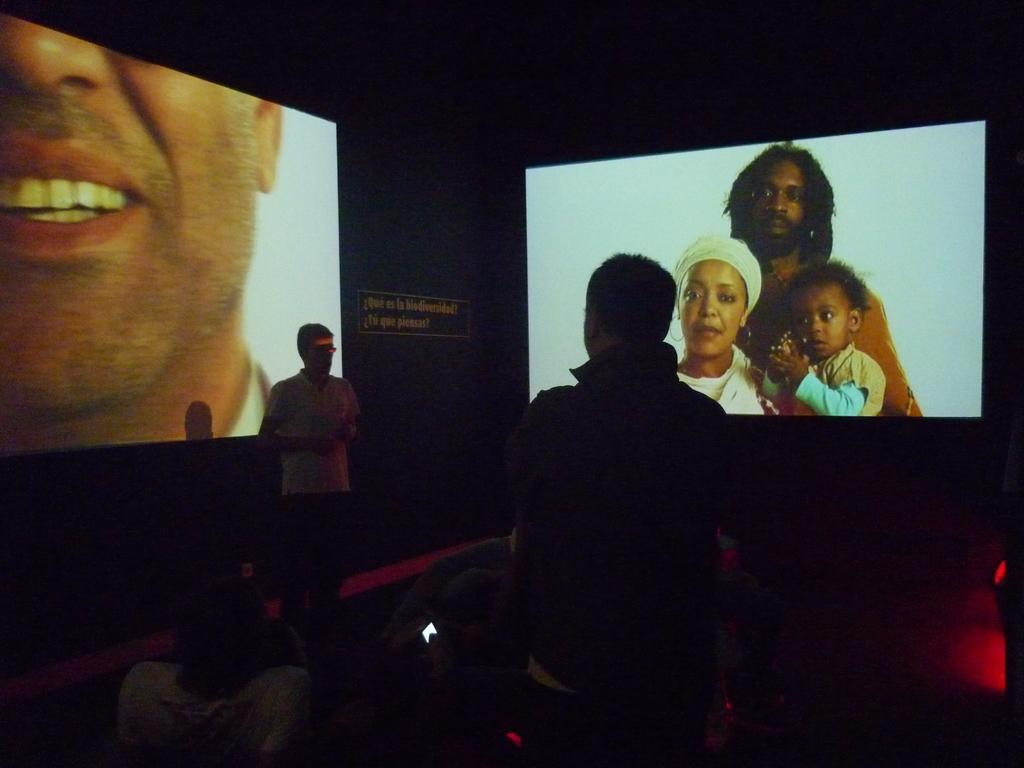What are the people in the image doing? There are people sitting on chairs and standing in the image. What can be seen in the background of the image? There is a screen in the background of the image. What is displayed on the screen? Pictures are displayed on the screen. Can you tell me how many locks are visible on the screen in the image? There are no locks visible on the screen in the image; it displays pictures. What type of doctor is standing next to the screen in the image? There is no doctor present in the image; it only shows people sitting on chairs, standing, and a screen with pictures. 